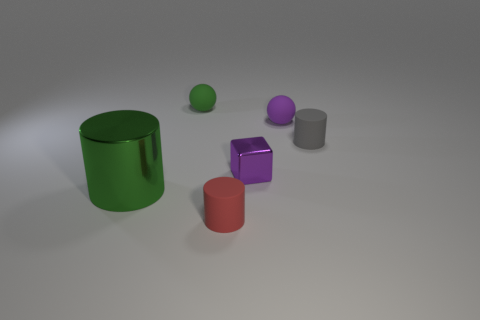Can you tell me the colors of the objects in the background? Certainly, in the background, there's a large green cylinder and a smaller grey cylinder. 